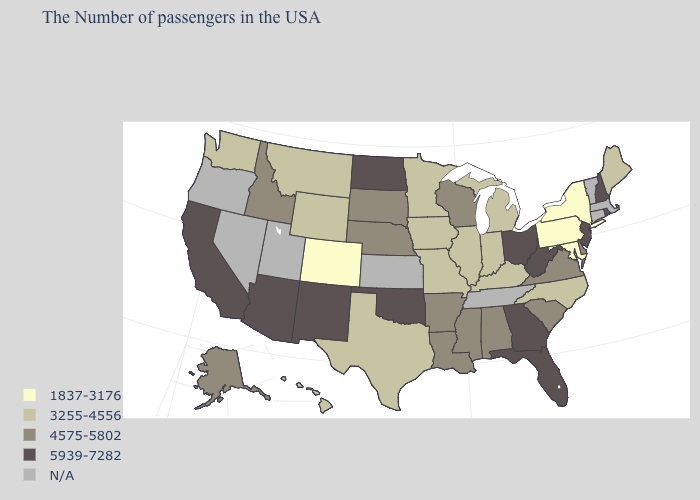Which states hav the highest value in the MidWest?
Be succinct. Ohio, North Dakota. What is the value of Indiana?
Give a very brief answer. 3255-4556. Name the states that have a value in the range 1837-3176?
Concise answer only. New York, Maryland, Pennsylvania, Colorado. What is the value of Louisiana?
Write a very short answer. 4575-5802. Name the states that have a value in the range 5939-7282?
Write a very short answer. Rhode Island, New Hampshire, New Jersey, West Virginia, Ohio, Florida, Georgia, Oklahoma, North Dakota, New Mexico, Arizona, California. Which states have the lowest value in the Northeast?
Write a very short answer. New York, Pennsylvania. Which states have the lowest value in the USA?
Be succinct. New York, Maryland, Pennsylvania, Colorado. What is the value of California?
Be succinct. 5939-7282. Is the legend a continuous bar?
Keep it brief. No. Name the states that have a value in the range 5939-7282?
Short answer required. Rhode Island, New Hampshire, New Jersey, West Virginia, Ohio, Florida, Georgia, Oklahoma, North Dakota, New Mexico, Arizona, California. Name the states that have a value in the range 4575-5802?
Give a very brief answer. Delaware, Virginia, South Carolina, Alabama, Wisconsin, Mississippi, Louisiana, Arkansas, Nebraska, South Dakota, Idaho, Alaska. How many symbols are there in the legend?
Concise answer only. 5. Which states hav the highest value in the South?
Answer briefly. West Virginia, Florida, Georgia, Oklahoma. How many symbols are there in the legend?
Keep it brief. 5. Does the first symbol in the legend represent the smallest category?
Answer briefly. Yes. 